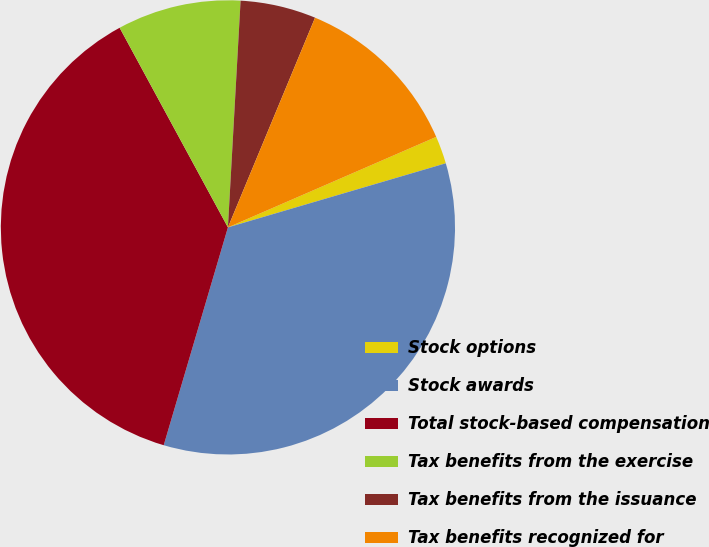<chart> <loc_0><loc_0><loc_500><loc_500><pie_chart><fcel>Stock options<fcel>Stock awards<fcel>Total stock-based compensation<fcel>Tax benefits from the exercise<fcel>Tax benefits from the issuance<fcel>Tax benefits recognized for<nl><fcel>1.97%<fcel>34.12%<fcel>37.53%<fcel>8.8%<fcel>5.38%<fcel>12.21%<nl></chart> 